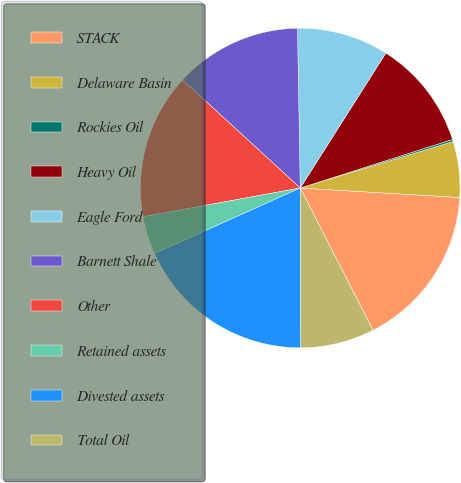<chart> <loc_0><loc_0><loc_500><loc_500><pie_chart><fcel>STACK<fcel>Delaware Basin<fcel>Rockies Oil<fcel>Heavy Oil<fcel>Eagle Ford<fcel>Barnett Shale<fcel>Other<fcel>Retained assets<fcel>Divested assets<fcel>Total Oil<nl><fcel>16.53%<fcel>5.65%<fcel>0.21%<fcel>11.09%<fcel>9.27%<fcel>12.9%<fcel>14.71%<fcel>3.84%<fcel>18.34%<fcel>7.46%<nl></chart> 